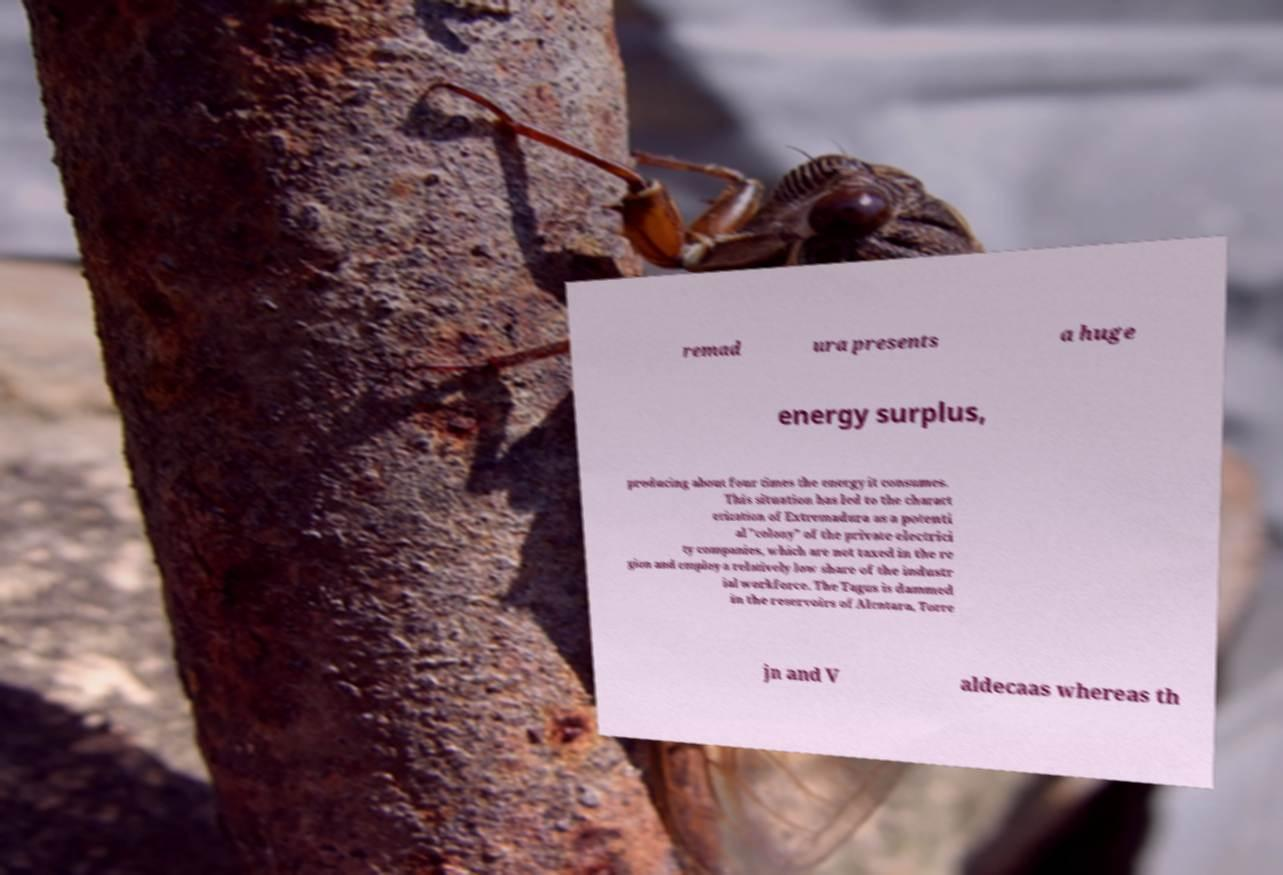Could you extract and type out the text from this image? remad ura presents a huge energy surplus, producing about four times the energy it consumes. This situation has led to the charact erization of Extremadura as a potenti al "colony" of the private electrici ty companies, which are not taxed in the re gion and employ a relatively low share of the industr ial workforce. The Tagus is dammed in the reservoirs of Alcntara, Torre jn and V aldecaas whereas th 